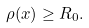<formula> <loc_0><loc_0><loc_500><loc_500>\rho ( x ) \geq R _ { 0 } .</formula> 